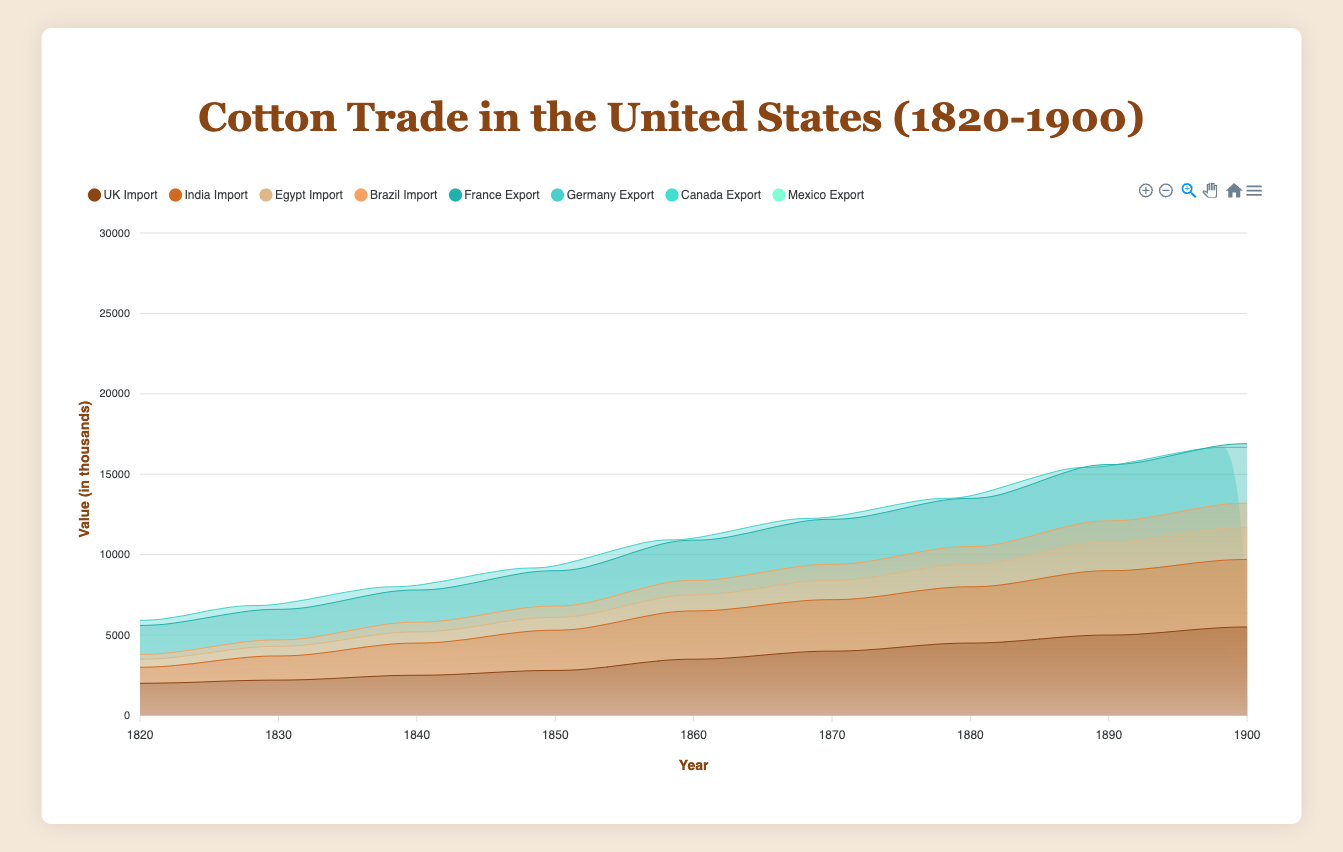What is the title of the figure? The title is located at the top of the figure and usually summarizes the main topic of the chart. In this case, it states "Cotton Trade in the United States (1820-1900)"
Answer: Cotton Trade in the United States (1820-1900) What periods does the x-axis cover? The x-axis represents the years between which data is displayed. Here, it starts at 1820 and ends at 1900, which can be confirmed by the tick marks on the x-axis that show these years
Answer: 1820 to 1900 Which country had the highest cotton import in 1900? To determine this, we observe the highest point on the import area charts for 1900. The highest point belongs to the United Kingdom, which has a value of 5500
Answer: United Kingdom What is the total value of cotton imports from Brazil in 1850? We need to find the value for Brazil's imports in 1850 from the series. The value listed for Brazil for 1850 is 700
Answer: 700 How did the import values from Egypt change from 1820 to 1900? Observing the import area for Egypt, we see that in 1820 the value was 500 and it increased over time to 2000 in 1900. This can be noted by comparing the start and end points of Egypt's import section
Answer: Increased from 500 to 2000 What is the average import value from India between 1820 and 1900? Summing up India’s import values from each decade (1000, 1500, 2000, 2500, 3000, 3200, 3500, 4000, 4200) and then dividing by the number of decades (9): (1000+1500+2000+2500+3000+3200+3500+4000+4200)/9 = 2767
Answer: 2767 Compare the export values to Canada and Mexico in 1880. Which country received more exports? We look at the values in 1880 for both countries. Canada received 2000 and Mexico received 1700 in exports. Since 2000 is greater than 1700, Canada received more
Answer: Canada Which import source showed the most significant increase from 1870 to 1900? To find the most significant increase, we calculate the difference for each country from 1870 to 1900. UK (4000 to 5500), India (3200 to 4200), Egypt (1200 to 2000), and Brazil (1000 to 1500) increase are 1500, 1000, 800, and 500 respectively. The UK shows the most significant increase (1500)
Answer: United Kingdom What is the combined value of exports to Germany and France in 1870? Adding the export values to Germany (2500) and France (2800) in 1870 gives us the combined total: 2500 + 2800 = 5300
Answer: 5300 Was there a consistent increase in imports from the United Kingdom from 1820 to 1900? Examining the data points for UK imports over the years (2000, 2200, 2500, 2800, 3500, 4000, 4500, 5000, 5500), we see a consistent increase over each decade
Answer: Yes 